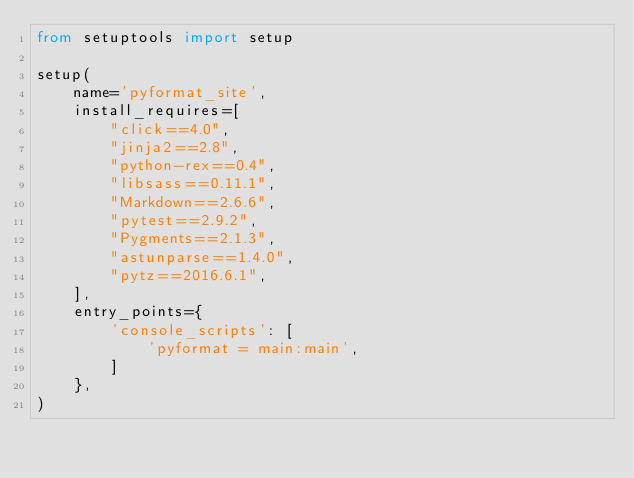Convert code to text. <code><loc_0><loc_0><loc_500><loc_500><_Python_>from setuptools import setup

setup(
    name='pyformat_site',
    install_requires=[
        "click==4.0",
        "jinja2==2.8",
        "python-rex==0.4",
        "libsass==0.11.1",
        "Markdown==2.6.6",
        "pytest==2.9.2",
        "Pygments==2.1.3",
        "astunparse==1.4.0",
        "pytz==2016.6.1",
    ],
    entry_points={
        'console_scripts': [
            'pyformat = main:main',
        ]
    },
)
</code> 